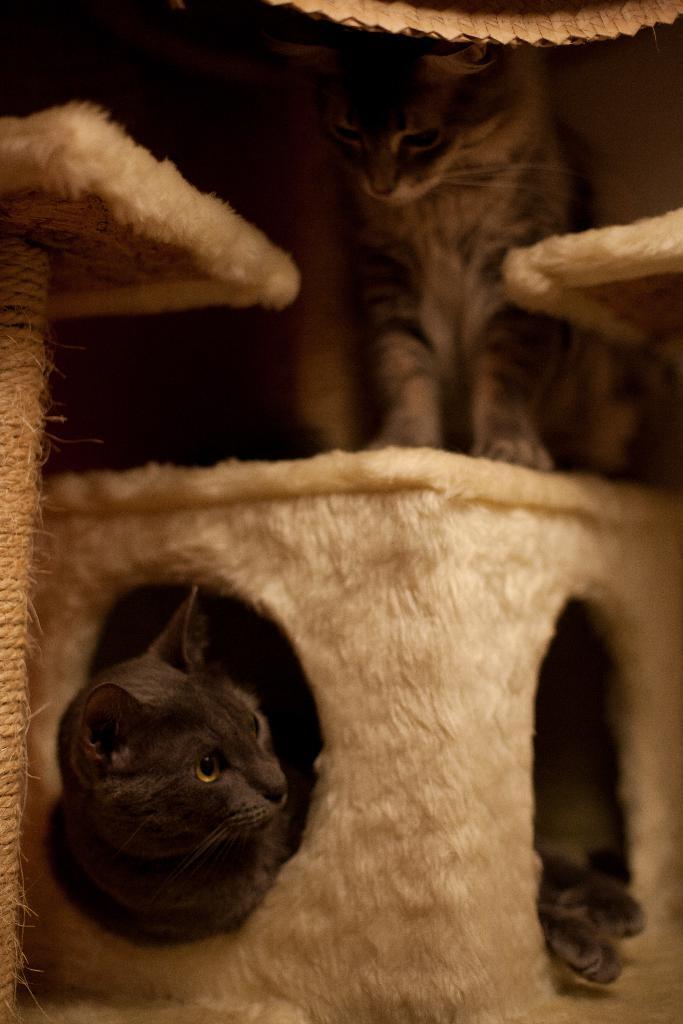Please provide a concise description of this image. This is the picture of a cat which is in the basket and also we can see the other cat on the basket and some other things around. 